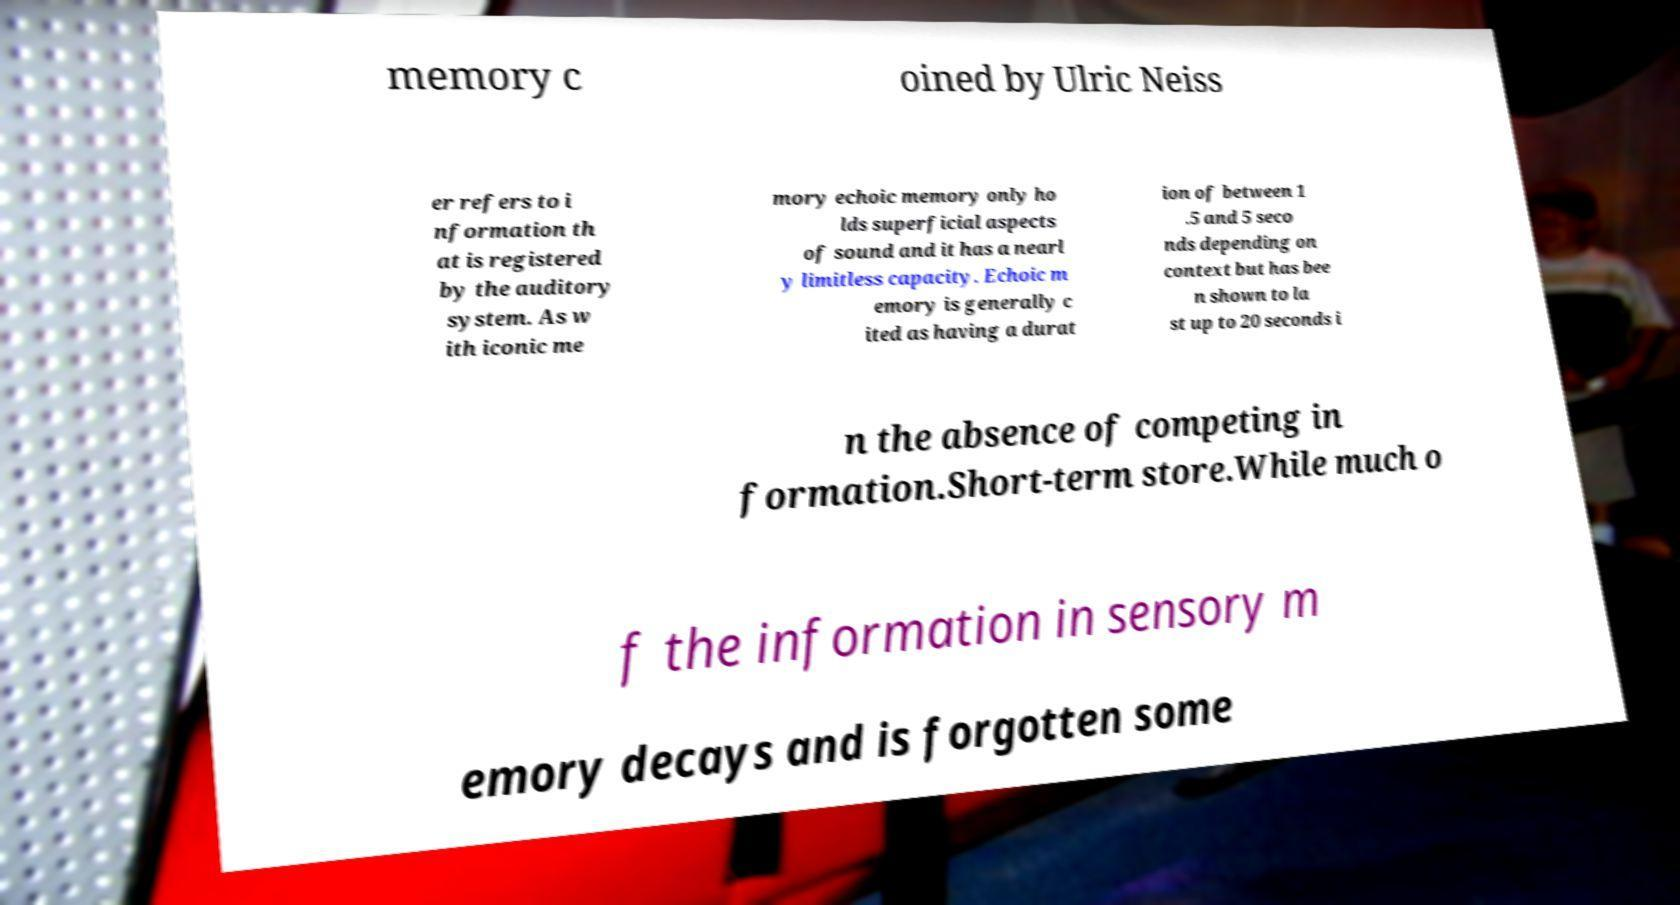There's text embedded in this image that I need extracted. Can you transcribe it verbatim? memory c oined by Ulric Neiss er refers to i nformation th at is registered by the auditory system. As w ith iconic me mory echoic memory only ho lds superficial aspects of sound and it has a nearl y limitless capacity. Echoic m emory is generally c ited as having a durat ion of between 1 .5 and 5 seco nds depending on context but has bee n shown to la st up to 20 seconds i n the absence of competing in formation.Short-term store.While much o f the information in sensory m emory decays and is forgotten some 